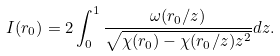Convert formula to latex. <formula><loc_0><loc_0><loc_500><loc_500>I ( r _ { 0 } ) = 2 \int _ { 0 } ^ { 1 } \frac { \omega ( r _ { 0 } / z ) } { \sqrt { \chi ( r _ { 0 } ) - \chi ( r _ { 0 } / z ) z ^ { 2 } } } d z .</formula> 